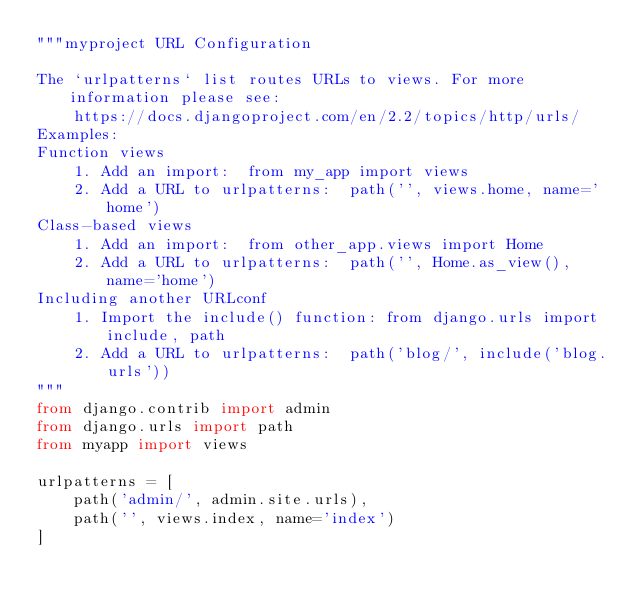<code> <loc_0><loc_0><loc_500><loc_500><_Python_>"""myproject URL Configuration

The `urlpatterns` list routes URLs to views. For more information please see:
    https://docs.djangoproject.com/en/2.2/topics/http/urls/
Examples:
Function views
    1. Add an import:  from my_app import views
    2. Add a URL to urlpatterns:  path('', views.home, name='home')
Class-based views
    1. Add an import:  from other_app.views import Home
    2. Add a URL to urlpatterns:  path('', Home.as_view(), name='home')
Including another URLconf
    1. Import the include() function: from django.urls import include, path
    2. Add a URL to urlpatterns:  path('blog/', include('blog.urls'))
"""
from django.contrib import admin
from django.urls import path
from myapp import views

urlpatterns = [
    path('admin/', admin.site.urls),
    path('', views.index, name='index')
]
</code> 